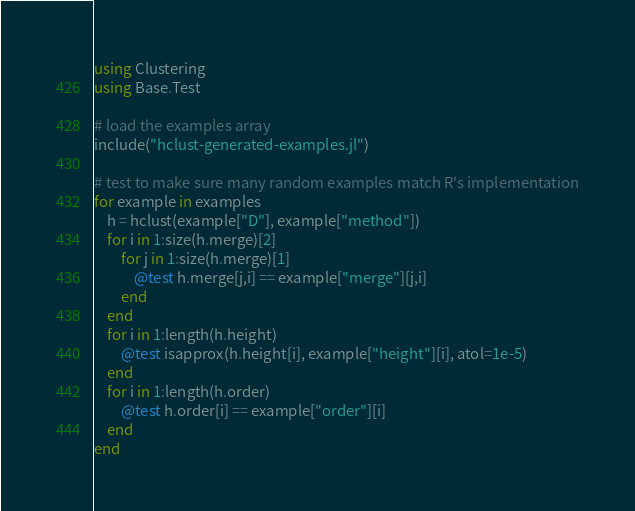<code> <loc_0><loc_0><loc_500><loc_500><_Julia_>using Clustering
using Base.Test

# load the examples array
include("hclust-generated-examples.jl")

# test to make sure many random examples match R's implementation
for example in examples
    h = hclust(example["D"], example["method"])
    for i in 1:size(h.merge)[2]
        for j in 1:size(h.merge)[1]
            @test h.merge[j,i] == example["merge"][j,i]
        end
    end
    for i in 1:length(h.height)
        @test isapprox(h.height[i], example["height"][i], atol=1e-5)
    end
    for i in 1:length(h.order)
        @test h.order[i] == example["order"][i]
    end
end
</code> 